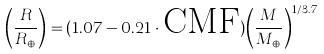<formula> <loc_0><loc_0><loc_500><loc_500>\left ( { \frac { R } { R _ { \oplus } } } \right ) = ( 1 . 0 7 - 0 . 2 1 \cdot \text {CMF} ) { \left ( { \frac { M } { M _ { \oplus } } } \right ) ^ { 1 / 3 . 7 } }</formula> 